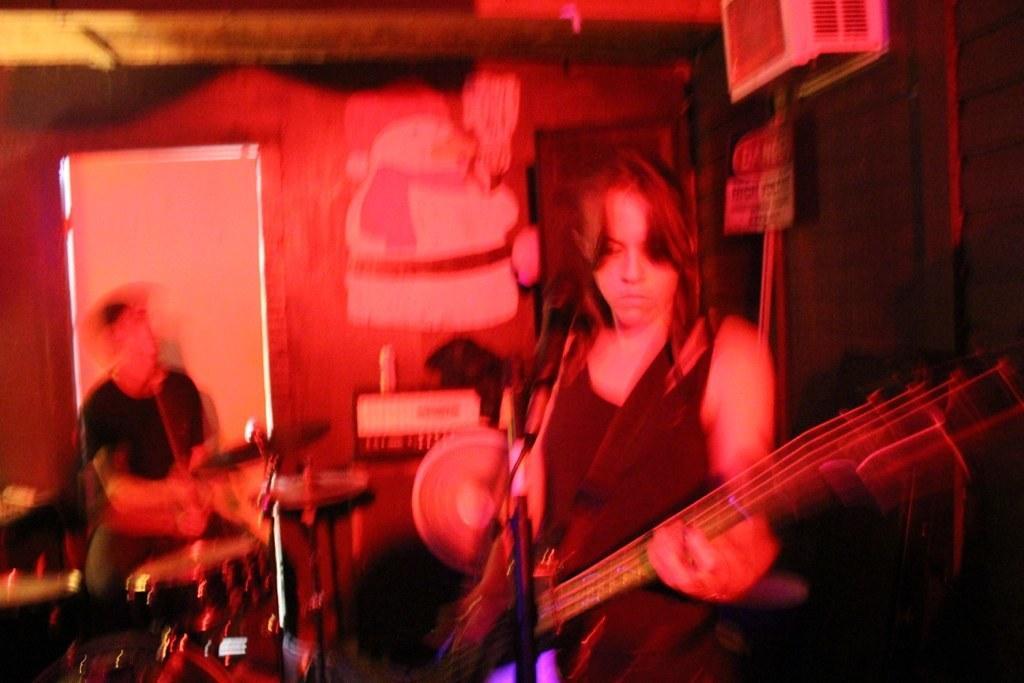Could you give a brief overview of what you see in this image? A girl is playing guitar with mic in front of her. 